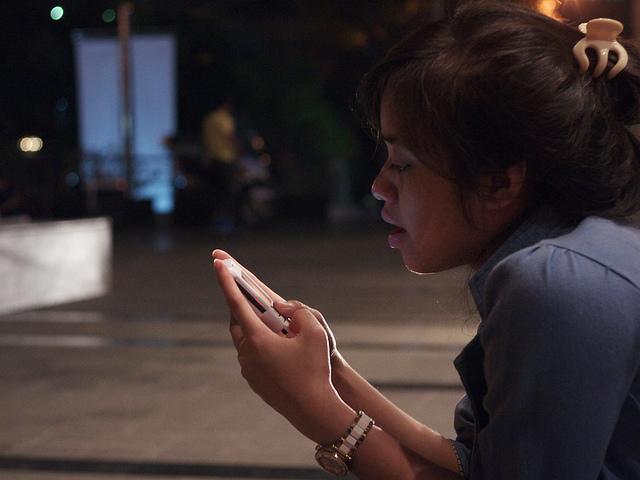How many girl are on the bench?
Give a very brief answer. 1. How many people can be seen?
Give a very brief answer. 3. 